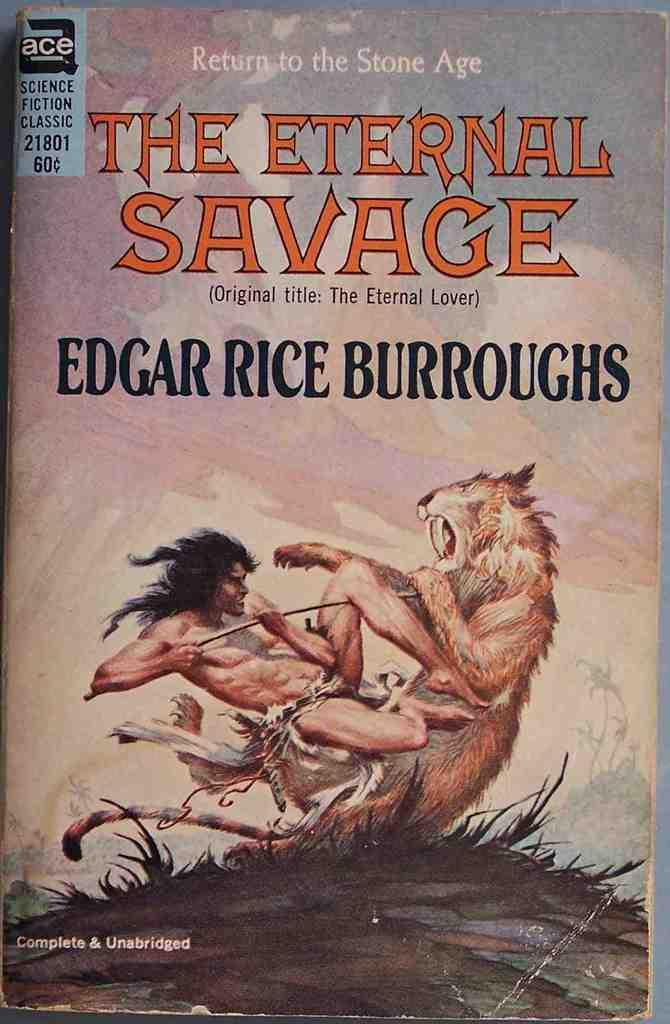Provide a one-sentence caption for the provided image. A book called "The Eternal Savage" by Edgar Rice Burroughs is shown with a man fighting a beast on its cover. 